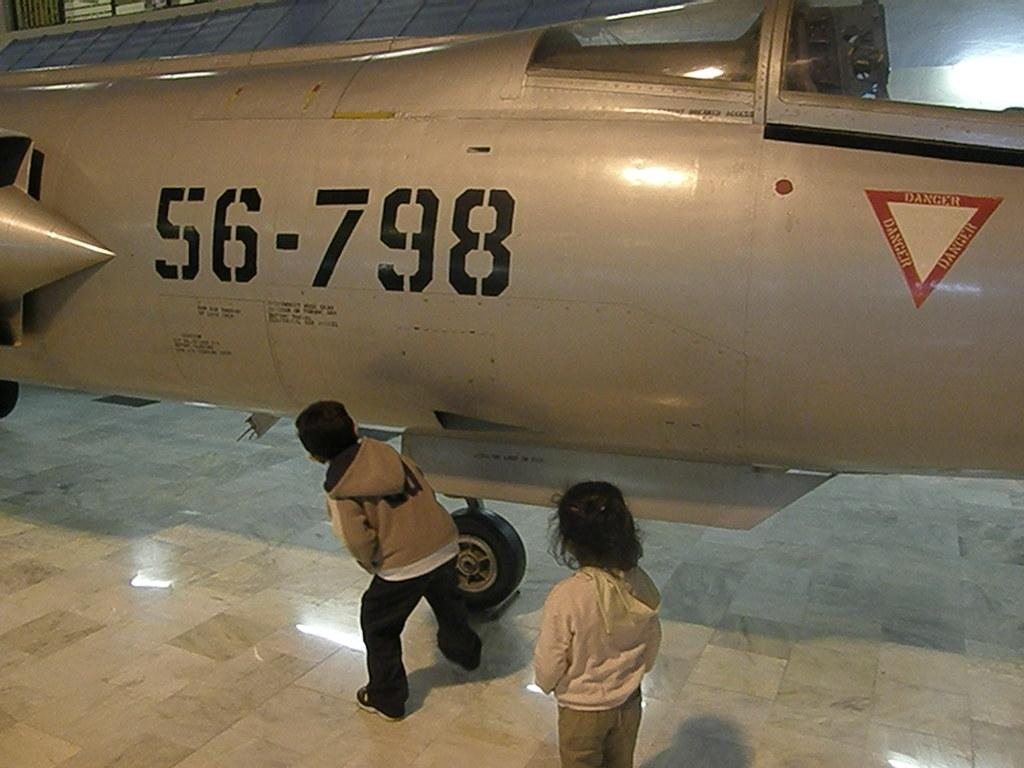Provide a one-sentence caption for the provided image. An airplane with 56-798 labeled on the side of the body. 